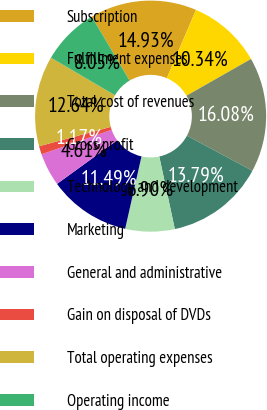Convert chart to OTSL. <chart><loc_0><loc_0><loc_500><loc_500><pie_chart><fcel>Subscription<fcel>Fulfillment expenses<fcel>Total cost of revenues<fcel>Gross profit<fcel>Technology and development<fcel>Marketing<fcel>General and administrative<fcel>Gain on disposal of DVDs<fcel>Total operating expenses<fcel>Operating income<nl><fcel>14.93%<fcel>10.34%<fcel>16.08%<fcel>13.79%<fcel>6.9%<fcel>11.49%<fcel>4.61%<fcel>1.17%<fcel>12.64%<fcel>8.05%<nl></chart> 